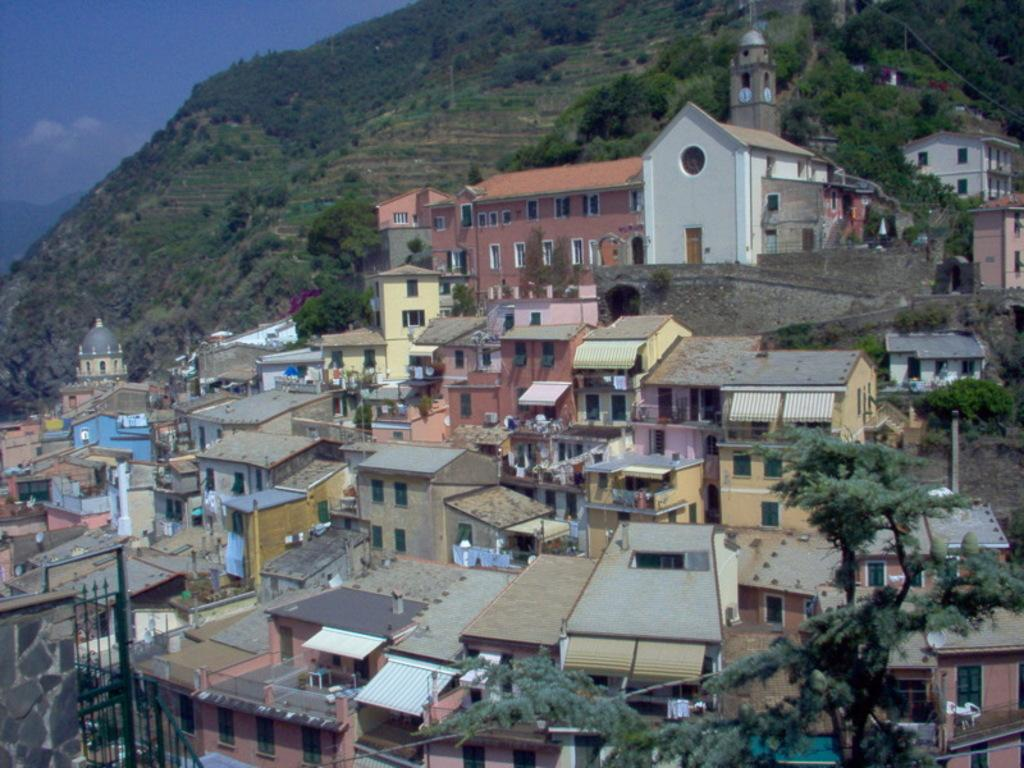What type of structures can be seen in the image? There are buildings in the image. What natural elements are present in the image? There are trees in the image. What architectural feature can be seen in the image? There is a wall in the image. What objects are used for cooking in the image? There are grills in the image. What geographical feature is visible at the top of the image? There is a hill at the top of the image. What part of the sky is visible in the image? The sky is present at the top left corner of the image. Can you see a net being used for a game in the image? There is no net present in the image. What type of pancake is being cooked on the grills in the image? There are no pancakes visible in the image; only grills are present. 